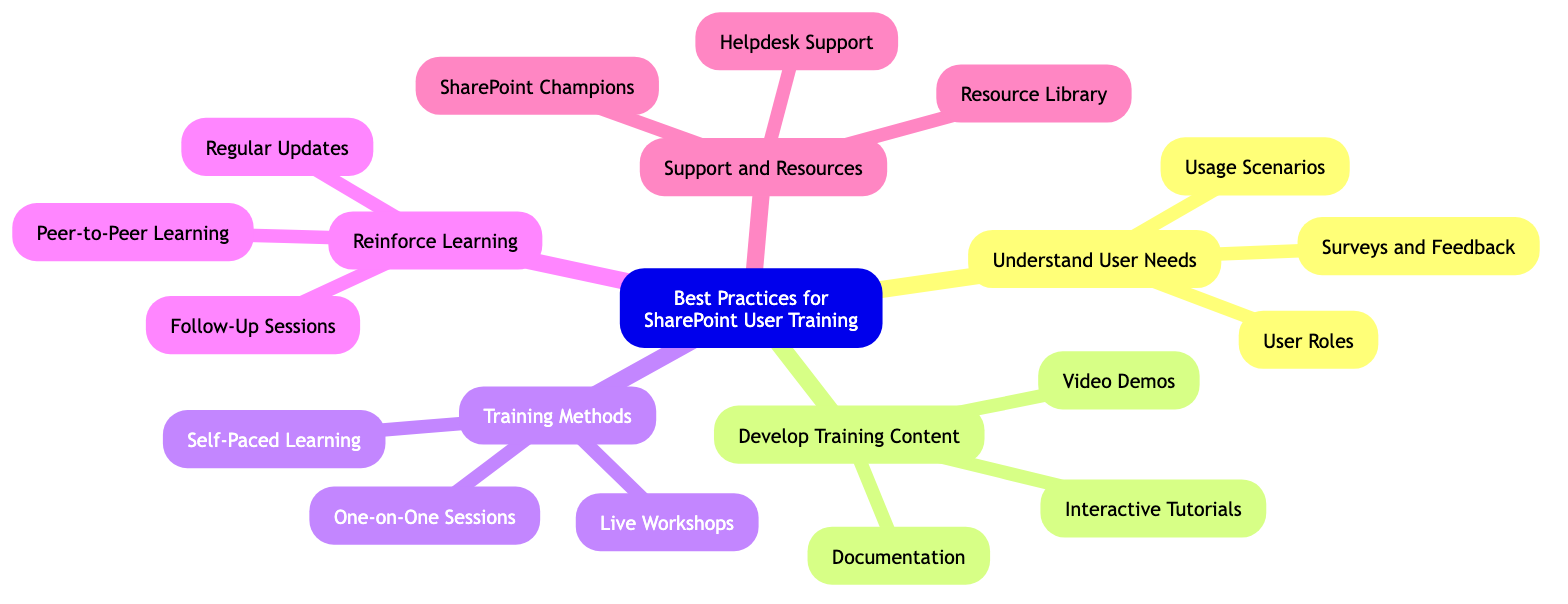What is the main topic of the mind map? The main topic is indicated at the root of the diagram, which is "Best Practices for SharePoint User Training."
Answer: Best Practices for SharePoint User Training How many main branches are there in the diagram? The main branches can be counted from the root node, which leads to five distinct branches: Understand User Needs, Develop Training Content, Training Methods, Reinforce Learning, and Support and Resources.
Answer: 5 What is one method for reinforcing learning? Each branch has specific methods listed below it. Under "Reinforce Learning," one of the methods is "Regular Updates."
Answer: Regular Updates Which branch includes "Live Workshops"? "Live Workshops" is listed under the "Training Methods" branch, which encompasses different approaches for training.
Answer: Training Methods How many specific topics are under "Develop Training Content"? Under "Develop Training Content," there are three specific topics or nodes listed, which are Interactive Tutorials, Video Demos, and Documentation.
Answer: 3 What relationship exists between "Peer-to-Peer Learning" and "Reinforce Learning"? "Peer-to-Peer Learning" is a specific method that directly contributes to the broader category of "Reinforce Learning," indicating a strategy for continuous education among users.
Answer: Peer-to-Peer Learning is a method of Reinforce Learning Which support resource is specifically designated for ongoing assistance? The node "Helpdesk Support" under the "Support and Resources" branch explicitly refers to the ongoing support resources provided to users.
Answer: Helpdesk Support What is a key focus when understanding user needs? "Surveys and Feedback" is the first specific topic under the "Understand User Needs" branch, highlighting the importance of collecting user feedback to understand their requirements.
Answer: Surveys and Feedback How can "SharePoint Champions" assist users? "SharePoint Champions," mentioned in the "Support and Resources" section, serves as empowered individuals within departments who promote usage and assist users with SharePoint-related issues.
Answer: Empower SharePoint Champions to assist users 